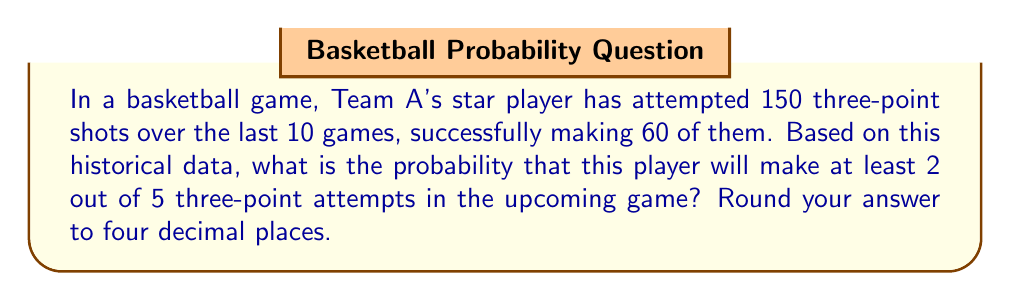Help me with this question. Let's approach this step-by-step:

1) First, we need to calculate the probability of a successful three-point shot based on the historical data:

   $p = \frac{\text{successful shots}}{\text{total attempts}} = \frac{60}{150} = 0.4$

2) Now, we want to find the probability of making at least 2 out of 5 attempts. This is equivalent to the probability of making 2, 3, 4, or 5 shots.

3) We can use the binomial probability formula for each case:

   $P(X=k) = \binom{n}{k} p^k (1-p)^{n-k}$

   Where $n$ is the number of trials (5), $k$ is the number of successes, $p$ is the probability of success (0.4), and $1-p$ is the probability of failure (0.6).

4) Let's calculate each probability:

   $P(X=2) = \binom{5}{2} (0.4)^2 (0.6)^3 = 10 \cdot 0.16 \cdot 0.216 = 0.3456$
   
   $P(X=3) = \binom{5}{3} (0.4)^3 (0.6)^2 = 10 \cdot 0.064 \cdot 0.36 = 0.2304$
   
   $P(X=4) = \binom{5}{4} (0.4)^4 (0.6)^1 = 5 \cdot 0.0256 \cdot 0.6 = 0.0768$
   
   $P(X=5) = \binom{5}{5} (0.4)^5 (0.6)^0 = 1 \cdot 0.01024 \cdot 1 = 0.01024$

5) The probability of making at least 2 shots is the sum of these probabilities:

   $P(X \geq 2) = P(X=2) + P(X=3) + P(X=4) + P(X=5)$
   
   $P(X \geq 2) = 0.3456 + 0.2304 + 0.0768 + 0.01024 = 0.66304$

6) Rounding to four decimal places:

   $P(X \geq 2) \approx 0.6630$
Answer: 0.6630 